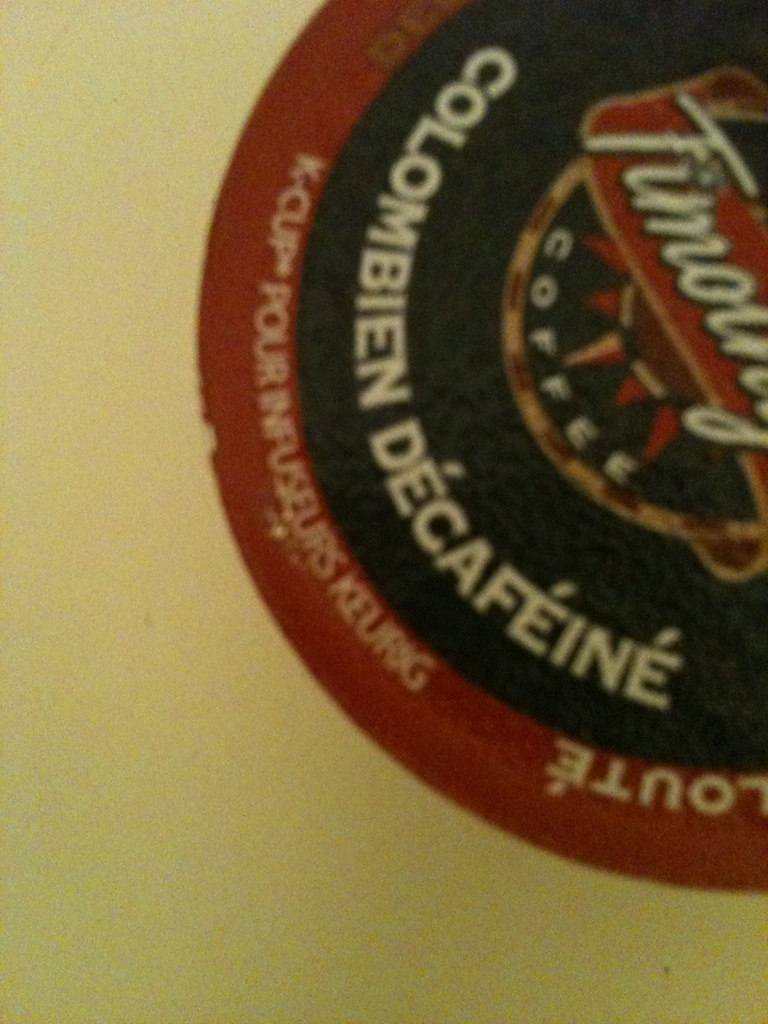Imagine if this coffee pod could talk. What story would it tell? If this coffee pod could talk, it would tell you about its journey from the lush coffee plantations nestled in the foothills of the Andes Mountains. It would recall the careful hands of the farmers who picked the beans at their peak ripeness, the meticulous process of decaffeination that preserved its rich flavor while removing the caffeine, and finally, the journey it took across continents to reach your kitchen. It would share stories of the families who rely on coffee farming, their traditions, and the vibrant culture of Colombia that infuses every bean with history and passion. What are some interesting culinary uses for coffee apart from drinking it? Coffee is a versatile ingredient and can be used in various culinary applications. It can add depth to savory dishes, like a coffee-rubbed steak, where ground coffee is mixed with spices and used as a marinade. Coffee-infused sauces and gravies can also enhance the flavor of meats. In baking, coffee is a common ingredient in cakes, cookies, and even bread, providing a rich, earthy flavor. It can also be used in cocktails or mocktails to create unique, flavorful drinks. 